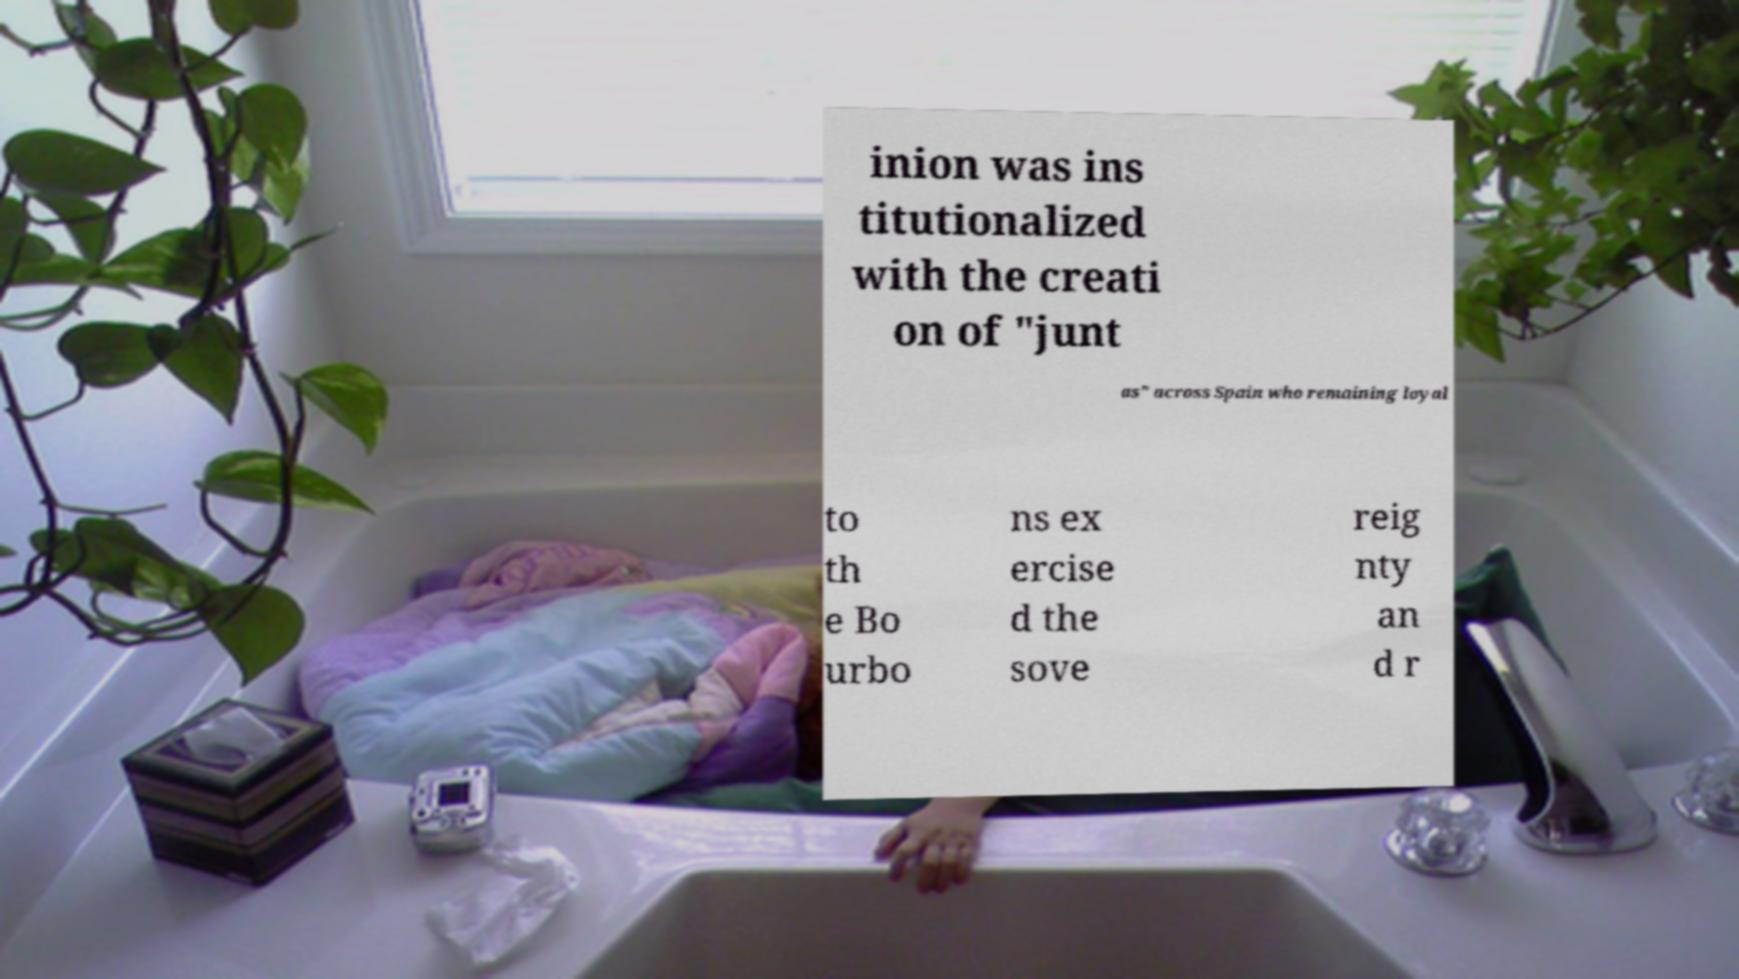Can you accurately transcribe the text from the provided image for me? inion was ins titutionalized with the creati on of "junt as" across Spain who remaining loyal to th e Bo urbo ns ex ercise d the sove reig nty an d r 